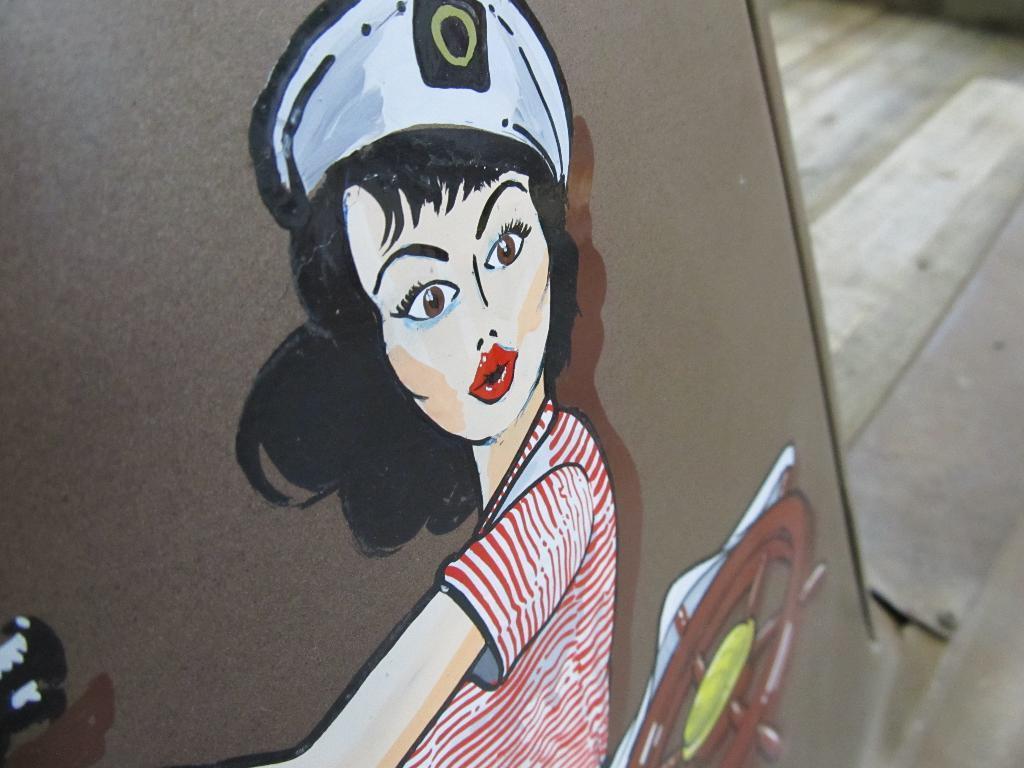How would you summarize this image in a sentence or two? In this image I can see a girl painting on the brown board. Girl is wearing red shirt and a white cap. 